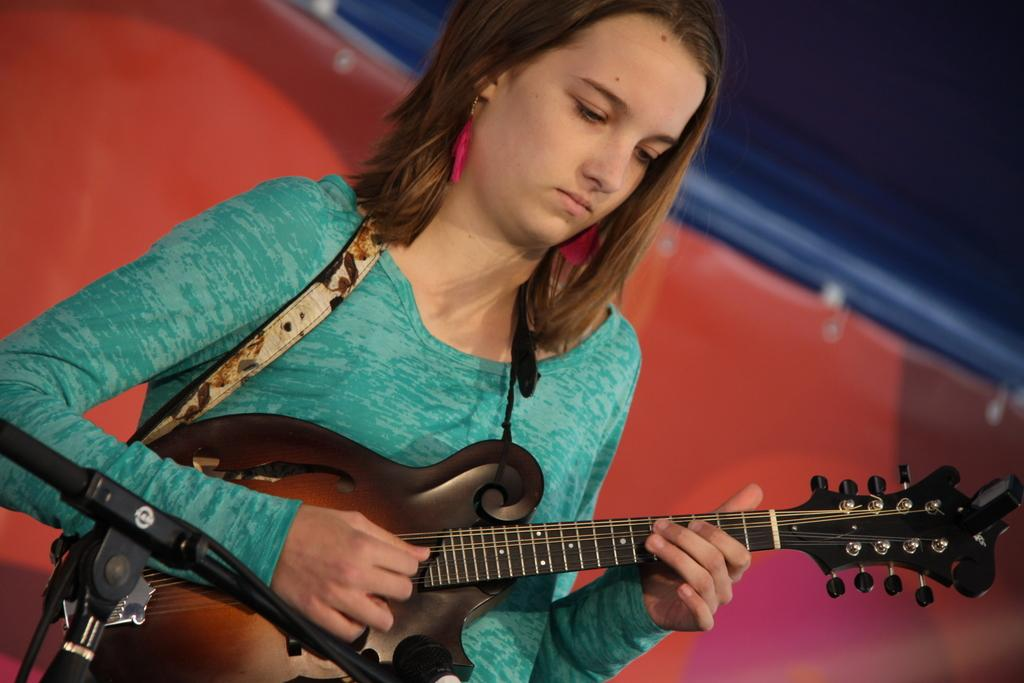What is the main subject of the image? There is a person in the image. What is the person doing in the image? The person is standing and playing a guitar. What is the person wearing in the image? The person is wearing a green t-shirt. What object is in front of the person in the image? There is a microphone stand in front of the person. What can be seen behind the person in the image? There is a red and blue background behind the person. Is the existence of bread confirmed in the image? There is no mention or presence of bread in the image. 